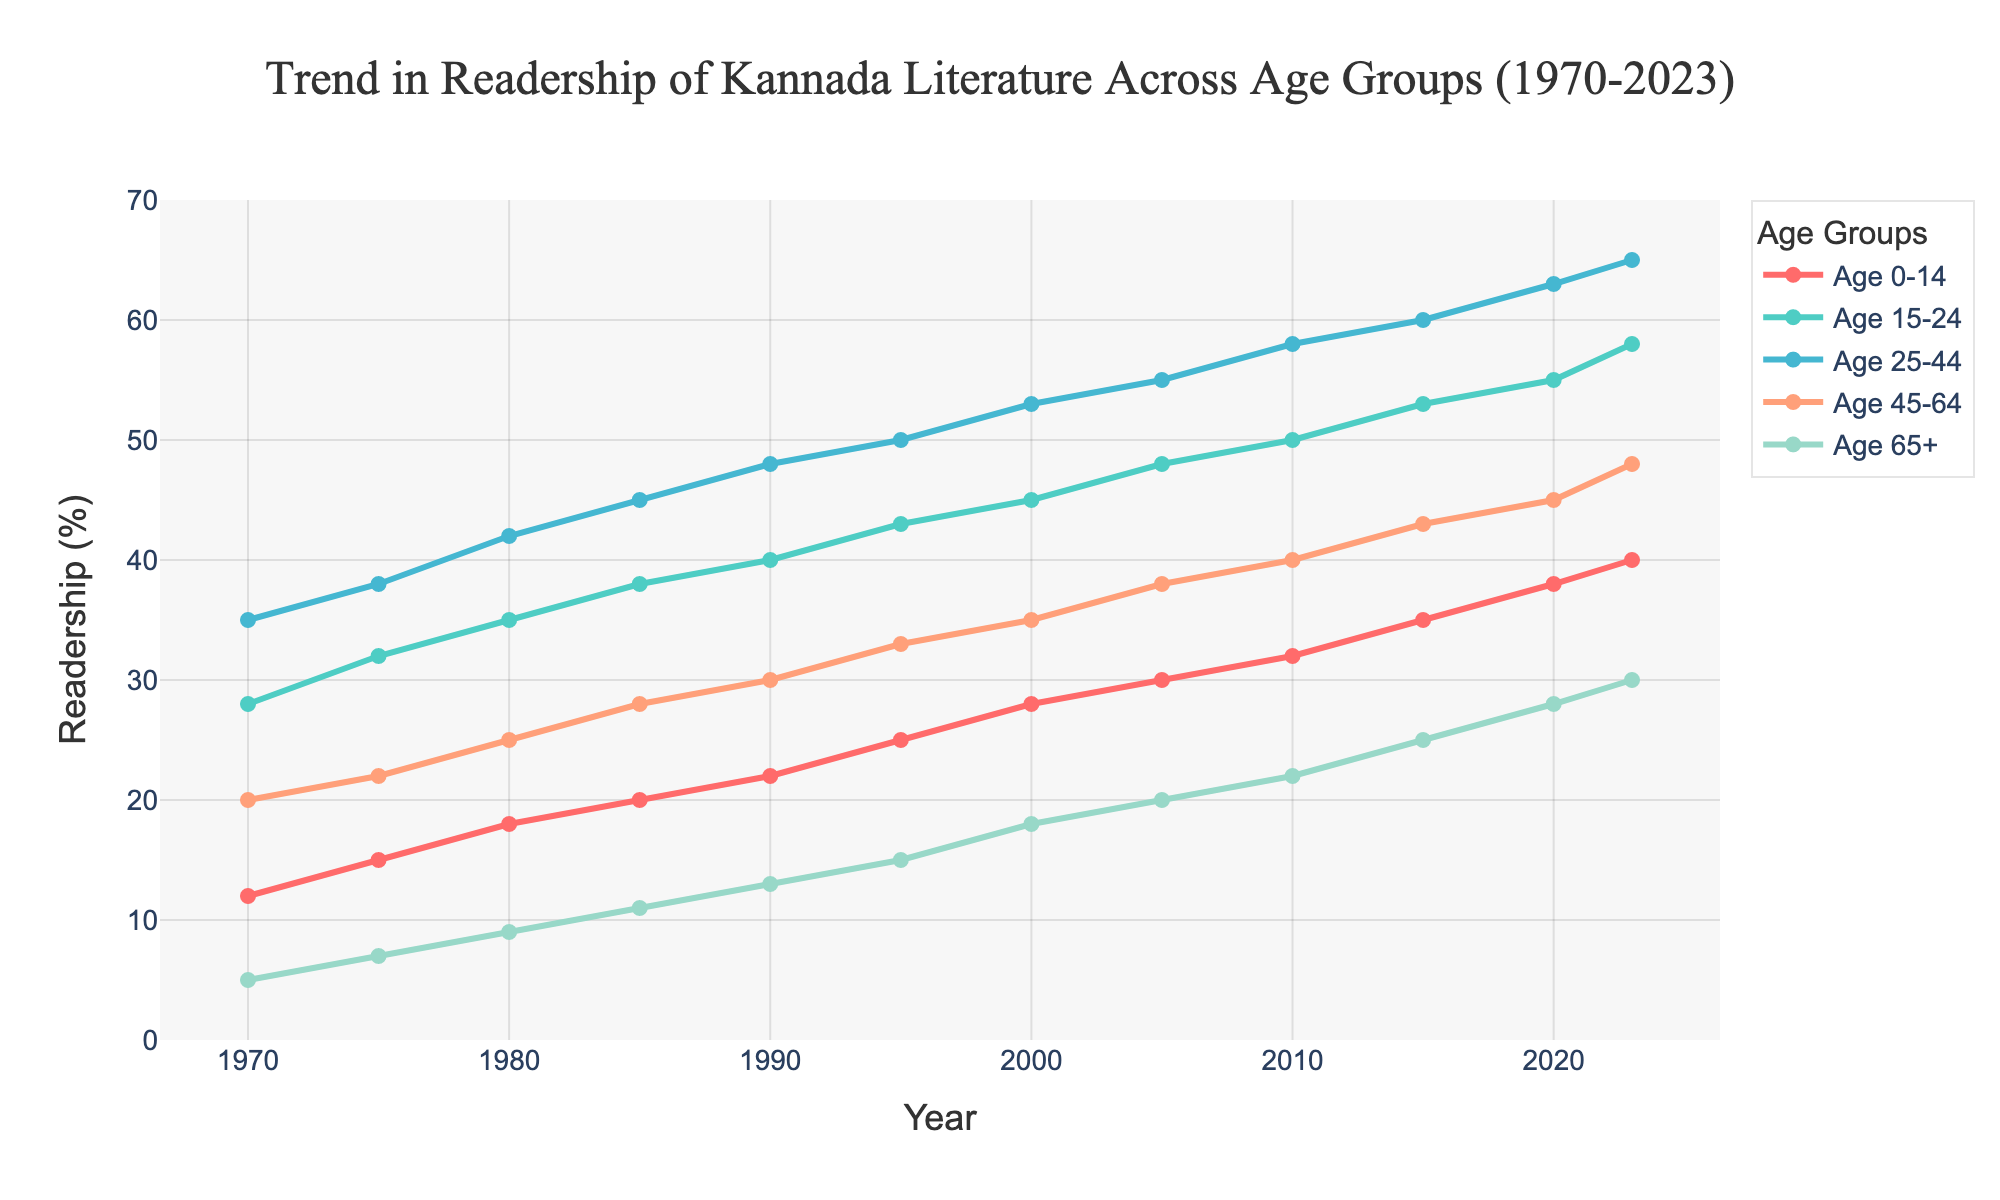What is the trend in readership for the Age 0-14 group between 1970 and 2023? By observing the plotted line for the Age 0-14 group (red line), we can see that the readership steadily increases from 12% in 1970 to 40% in 2023, indicating a consistent rise over the years.
Answer: Increasing In which year did the Age 25-44 group first surpass 50% readership? By tracing the Age 25-44 line (green line) and observing the values, we see that readership reached 53% in the year 2000.
Answer: 2000 Which age group had the highest readership percentage in 2023? By comparing the endpoints of all the age group lines in the year 2023, it is evident that the Age 25-44 group (green line) has the highest value at 65%.
Answer: Age 25-44 Which age group's readership percentage grew the most from 1970 to 2023? To find the age group with the most significant growth, we calculate the difference in readership from 1970 to 2023 for each group. Age 0-14: 40-12 = 28, Age 15-24: 58-28 = 30, Age 25-44: 65-35 = 30, Age 45-64: 48-20 = 28, Age 65+: 30-5 = 25. The Age 15-24 and Age 25-44 groups have the highest growth of 30%.
Answer: Age 15-24 and Age 25-44 What is the combined readership percentage for all age groups in 2023? Adding the readership percentages for all age groups in 2023: 40 (Age 0-14) + 58 (Age 15-24) + 65 (Age 25-44) + 48 (Age 45-64) + 30 (Age 65+) results in a total of 241%.
Answer: 241% Which age group had the smallest readership percentage in 1990, and what was the percentage? By examining the plotted lines for 1990, the Age 0-14 group (red line) had the smallest percentage at 22%.
Answer: Age 0-14, 22% How does the readership trend for the Age 45-64 group compare to the Age 65+ group from 1970 to 2023? By observing the trends for both Age 45-64 (orange line) and Age 65+ (blue line), each shows a steady increase over the years. However, Age 45-64 has consistently higher percentages compared to Age 65+ throughout the entire period.
Answer: Age 45-64 is consistently higher What is the difference in readership percentage between the Age 45-64 group and the Age 65+ group in 2023? Subtracting the readership percentages in 2023 for Age 65+ (30%) from Age 45-64 (48%) gives us a difference of 48 - 30 = 18%.
Answer: 18% Which age group shows the steepest increase in readership between 2000 and 2023? By comparing the slopes of the lines for each age group from 2000 to 2023, the steepest increase is observed in the Age 15-24 group (cyan line), rising from 45% to 58%, yielding a 13% increase.
Answer: Age 15-24 How did the readership percentage for the Age 0-14 group change from 1995 to 2005? Observing the red line for Age 0-14 between 1995 and 2005, the readership increased from 25% to 30%, which is a 5% rise over this period.
Answer: Increased by 5% 